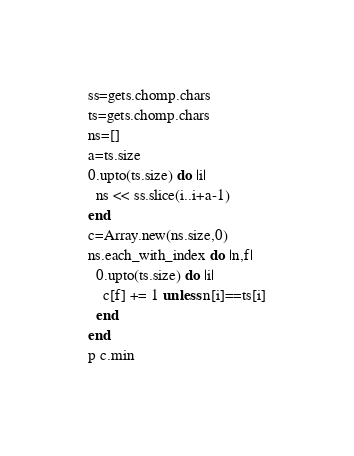<code> <loc_0><loc_0><loc_500><loc_500><_Ruby_>ss=gets.chomp.chars
ts=gets.chomp.chars
ns=[]
a=ts.size
0.upto(ts.size) do |i|
  ns << ss.slice(i..i+a-1)
end
c=Array.new(ns.size,0)
ns.each_with_index do |n,f|
  0.upto(ts.size) do |i|
    c[f] += 1 unless n[i]==ts[i]
  end
end
p c.min</code> 